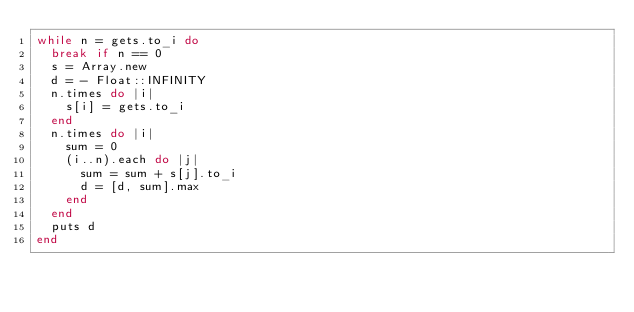Convert code to text. <code><loc_0><loc_0><loc_500><loc_500><_Ruby_>while n = gets.to_i do
  break if n == 0
  s = Array.new
  d = - Float::INFINITY
  n.times do |i|
    s[i] = gets.to_i
  end
  n.times do |i|
    sum = 0
    (i..n).each do |j|
      sum = sum + s[j].to_i
      d = [d, sum].max
    end
  end
  puts d
end</code> 